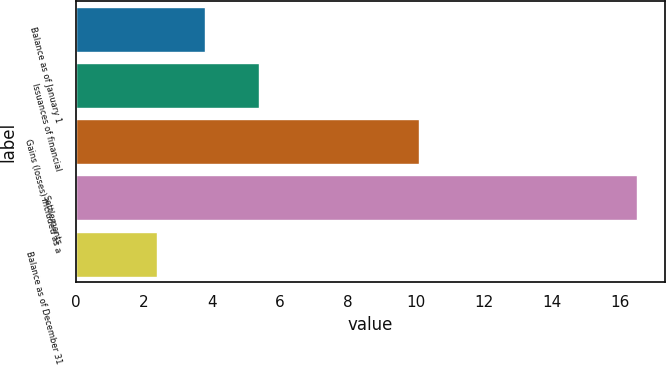Convert chart to OTSL. <chart><loc_0><loc_0><loc_500><loc_500><bar_chart><fcel>Balance as of January 1<fcel>Issuances of financial<fcel>Gains (losses) included as a<fcel>Settlements<fcel>Balance as of December 31<nl><fcel>3.81<fcel>5.4<fcel>10.1<fcel>16.5<fcel>2.4<nl></chart> 